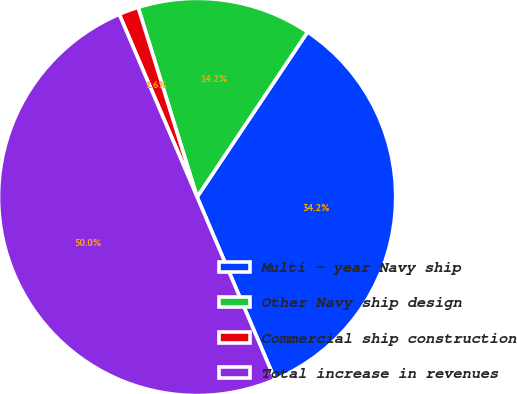Convert chart. <chart><loc_0><loc_0><loc_500><loc_500><pie_chart><fcel>Multi - year Navy ship<fcel>Other Navy ship design<fcel>Commercial ship construction<fcel>Total increase in revenues<nl><fcel>34.2%<fcel>14.19%<fcel>1.61%<fcel>50.0%<nl></chart> 